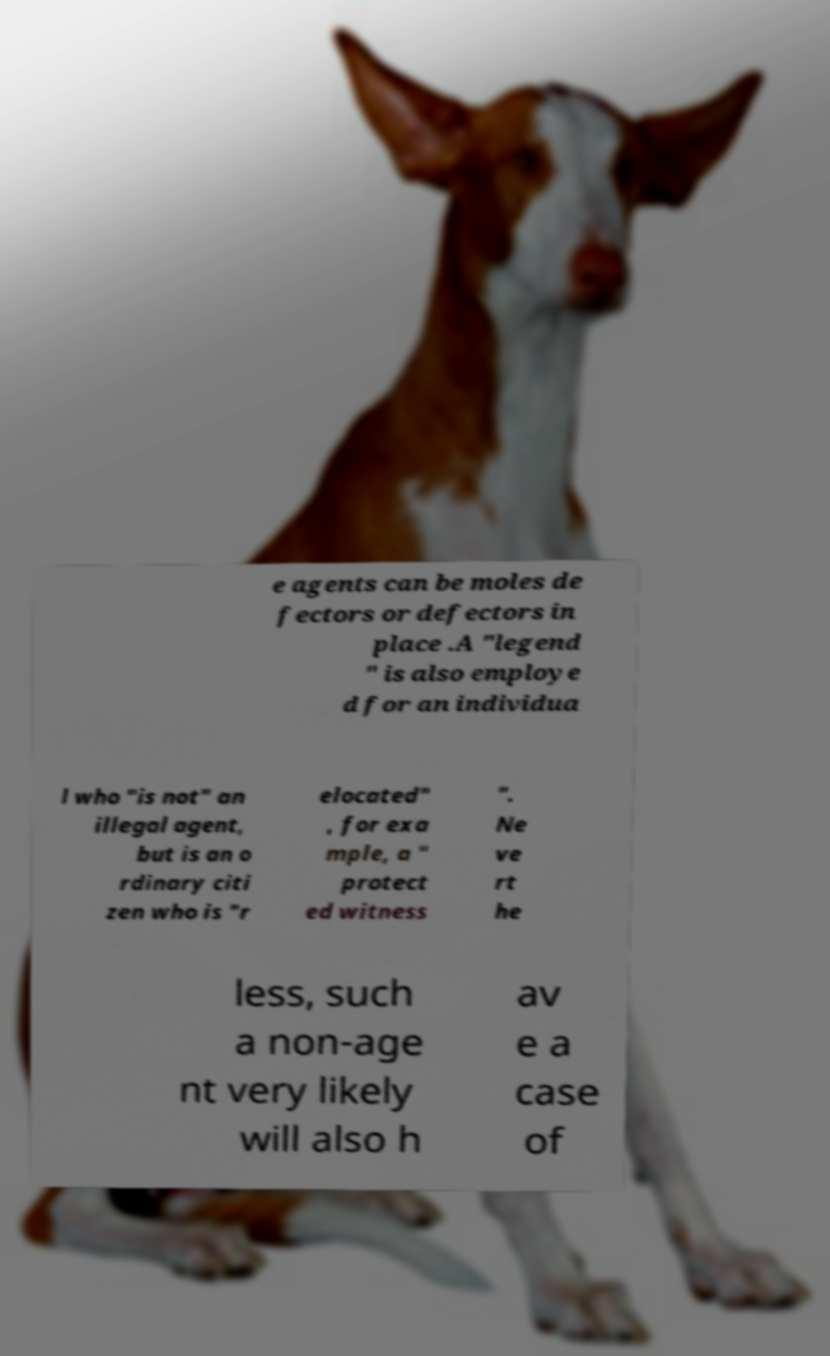Can you read and provide the text displayed in the image?This photo seems to have some interesting text. Can you extract and type it out for me? e agents can be moles de fectors or defectors in place .A "legend " is also employe d for an individua l who "is not" an illegal agent, but is an o rdinary citi zen who is "r elocated" , for exa mple, a " protect ed witness ". Ne ve rt he less, such a non-age nt very likely will also h av e a case of 